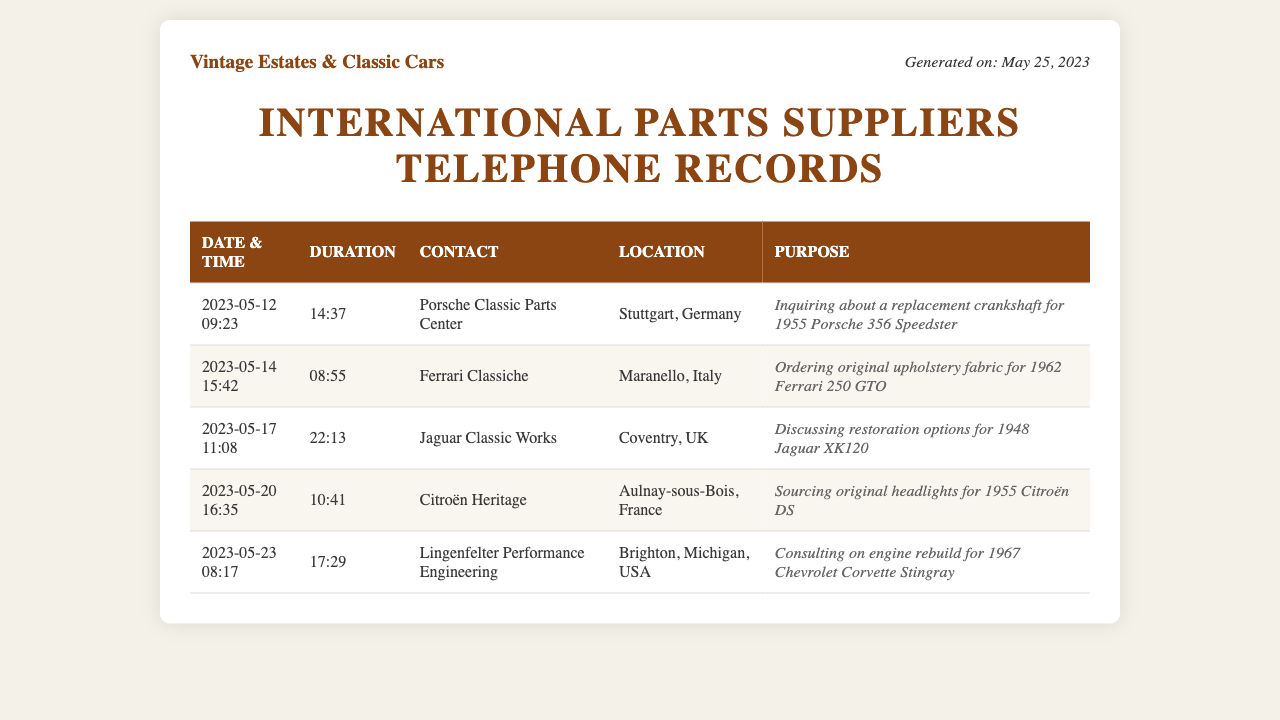What was the longest call duration? The longest call duration can be found by comparing the duration of all calls listed in the table. The longest duration is 22:13.
Answer: 22:13 Which company was contacted for upholstery fabric? The company associated with ordering upholstery fabric appears in the "Contact" column for that specific entry. It is Ferrari Classiche.
Answer: Ferrari Classiche What date was the call made to Jaguar Classic Works? The date for the call to Jaguar Classic Works is in the "Date & Time" column for that entry. It is 2023-05-17.
Answer: 2023-05-17 How many suppliers are listed in the document? The number of suppliers can be determined by counting the entries in the table. There are five suppliers.
Answer: 5 Which part was sourced from Citroën Heritage? The specific part that was sourced can be found in the "Purpose" column relating to Citroën Heritage. It is original headlights.
Answer: original headlights What is the location of Lingenfelter Performance Engineering? The location is included in the "Location" column of the table. It is Brighton, Michigan, USA.
Answer: Brighton, Michigan, USA Which car was discussed with Porsche Classic Parts Center? The car discussed is related to the "Purpose" entry for Porsche Classic Parts Center. It is the 1955 Porsche 356 Speedster.
Answer: 1955 Porsche 356 Speedster What was the inquiry about during the call to Citroën Heritage? The inquiry can be identified in the "Purpose" column where it states the intention of the call. It is sourcing original headlights.
Answer: sourcing original headlights 